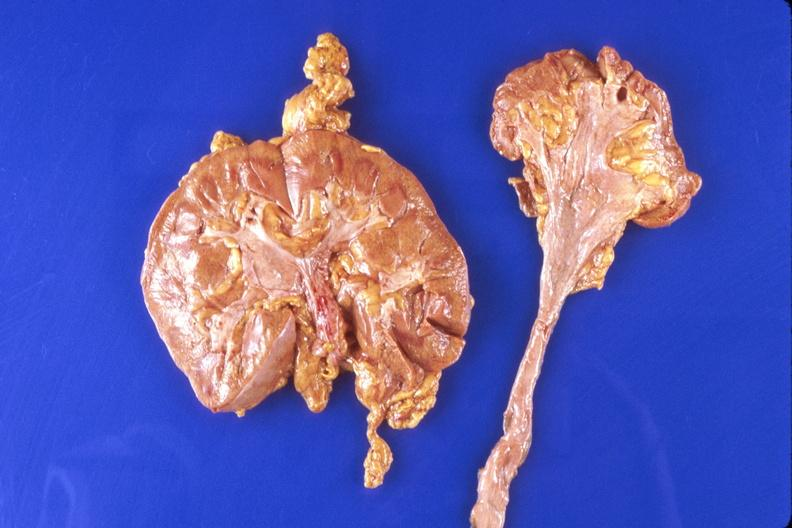does lymph node show kidney, hypoplasia and compensatory hypertrophy of contralateral kidney?
Answer the question using a single word or phrase. No 